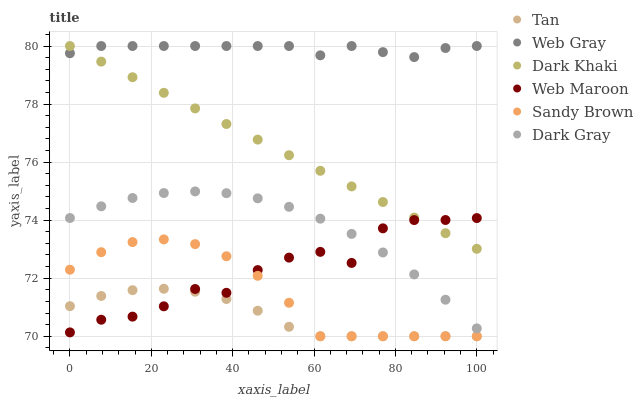Does Tan have the minimum area under the curve?
Answer yes or no. Yes. Does Web Gray have the maximum area under the curve?
Answer yes or no. Yes. Does Web Maroon have the minimum area under the curve?
Answer yes or no. No. Does Web Maroon have the maximum area under the curve?
Answer yes or no. No. Is Dark Khaki the smoothest?
Answer yes or no. Yes. Is Web Maroon the roughest?
Answer yes or no. Yes. Is Web Gray the smoothest?
Answer yes or no. No. Is Web Gray the roughest?
Answer yes or no. No. Does Tan have the lowest value?
Answer yes or no. Yes. Does Web Maroon have the lowest value?
Answer yes or no. No. Does Dark Khaki have the highest value?
Answer yes or no. Yes. Does Web Maroon have the highest value?
Answer yes or no. No. Is Tan less than Dark Khaki?
Answer yes or no. Yes. Is Dark Khaki greater than Tan?
Answer yes or no. Yes. Does Dark Gray intersect Web Maroon?
Answer yes or no. Yes. Is Dark Gray less than Web Maroon?
Answer yes or no. No. Is Dark Gray greater than Web Maroon?
Answer yes or no. No. Does Tan intersect Dark Khaki?
Answer yes or no. No. 